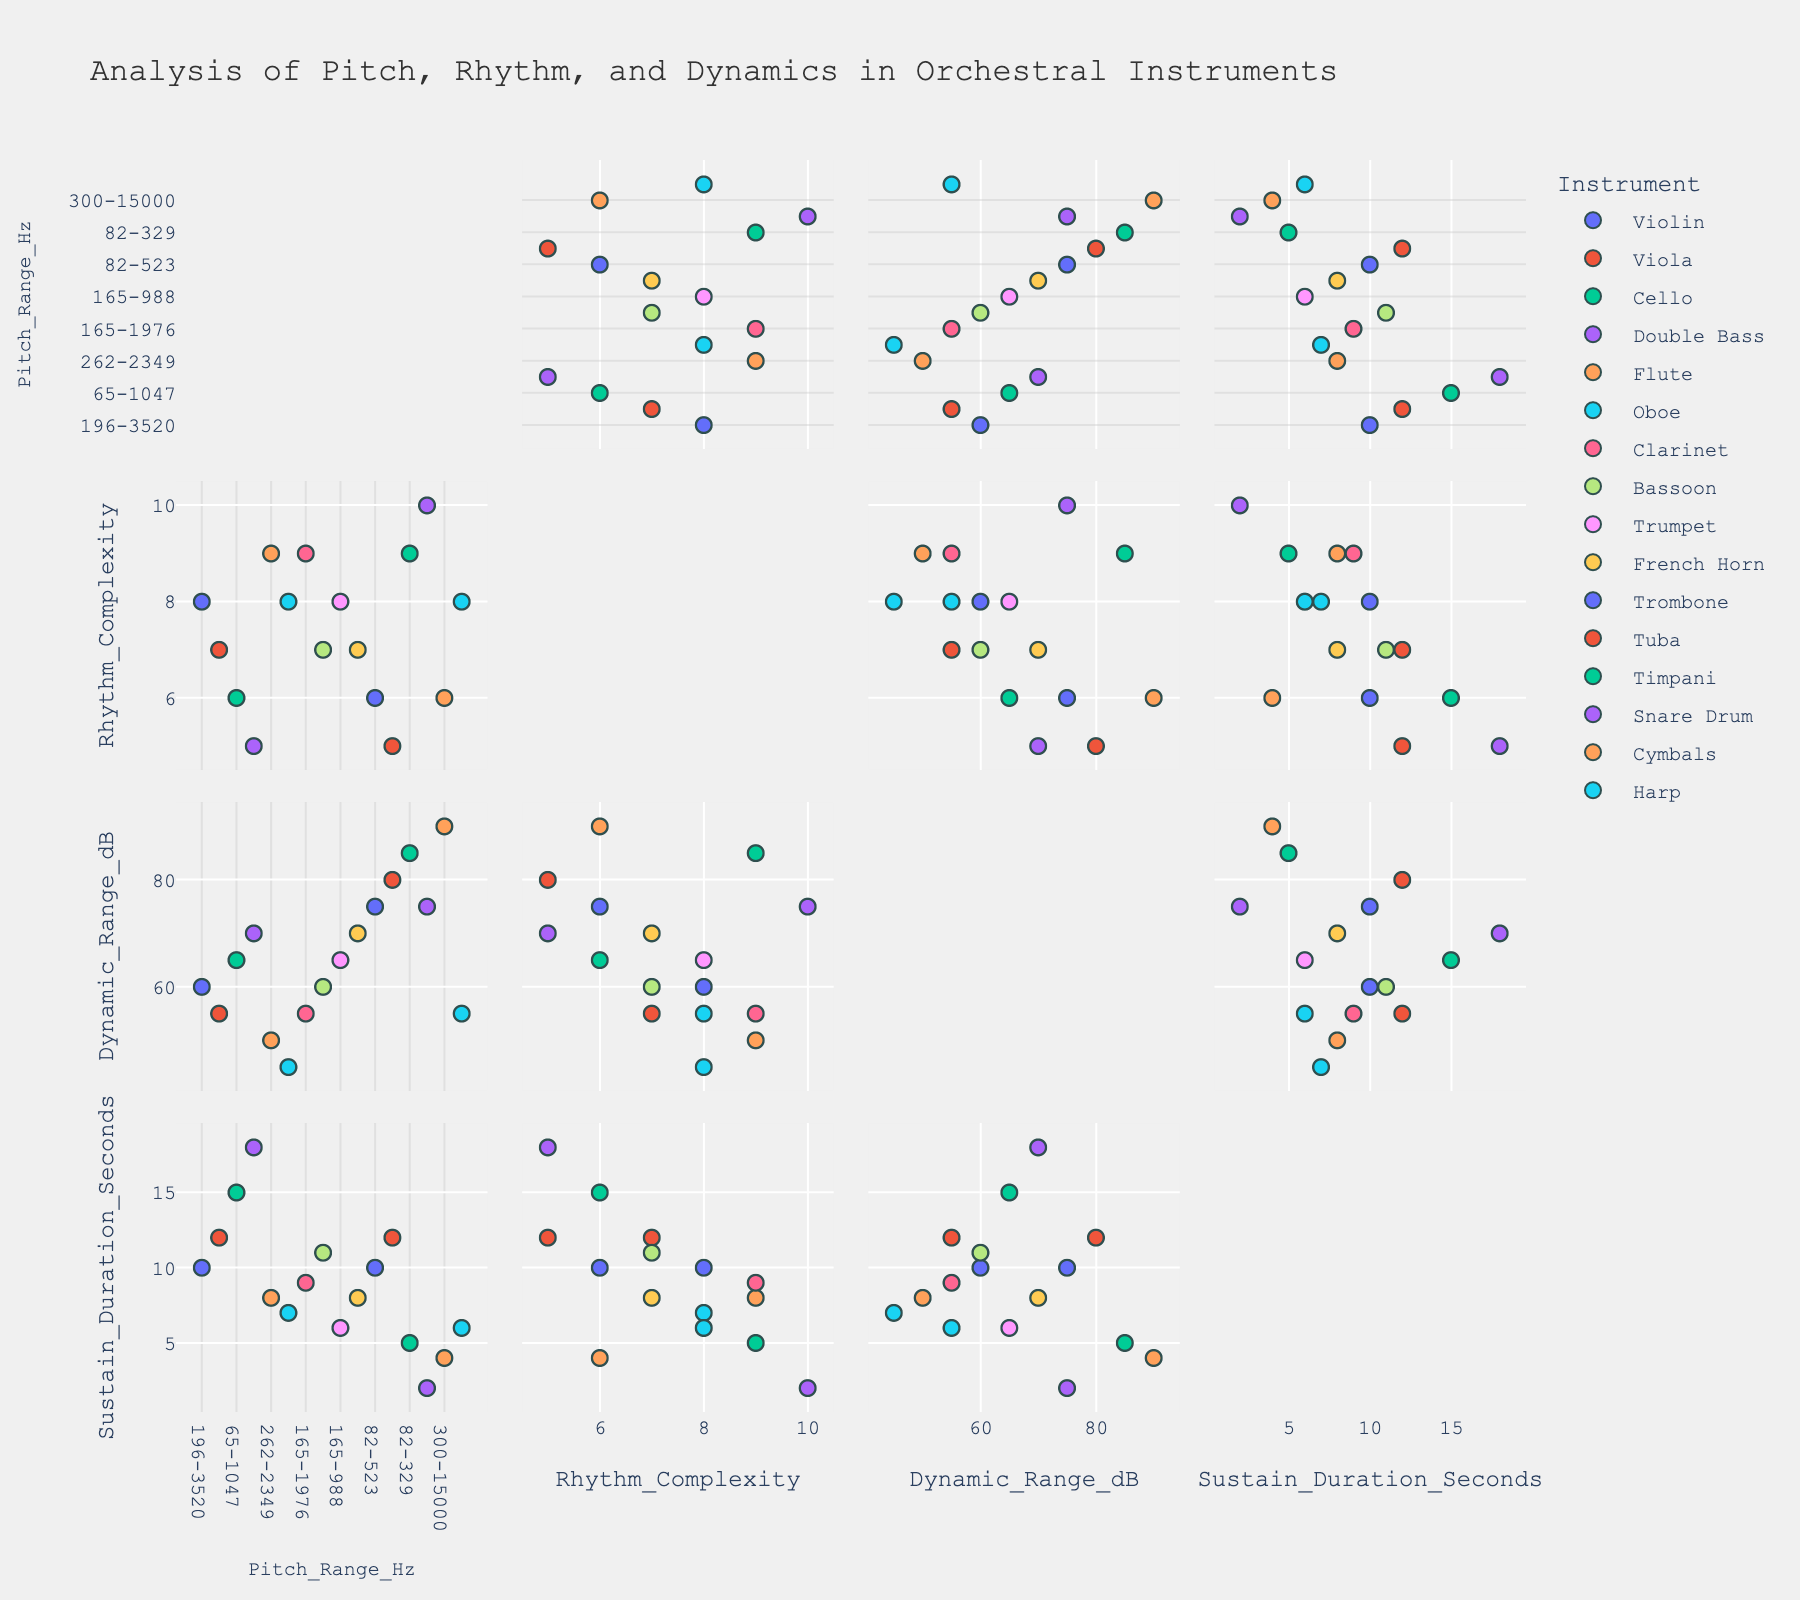What's the range of Pitch_Range_Hz for the Violin? By identifying the Violin's data point in the scatter plot matrix and reading the corresponding Pitch_Range_Hz value, we find it to be 196-3520 Hz.
Answer: 196-3520 Hz Which instrument has the highest Dynamic_Range_dB? Identify the data point with the highest value in the Dynamic_Range_dB axis. The highest point corresponds to the Cymbals with a dynamic range of 90 dB.
Answer: Cymbals What is the average Sustain_Duration_Seconds for the Double Bass and Cello? Locate the data points for the Double Bass and Cello, noting their Sustain_Duration_Seconds values: 18 and 15 seconds respectively. The average is calculated as (18 + 15) / 2 = 16.5 seconds.
Answer: 16.5 seconds Do woodwind instruments generally have higher Rhythm_Complexity than brass instruments? Compare the Rhythm_Complexity values of woodwind instruments (Flute, Oboe, Clarinet, Bassoon) with those of brass instruments (Trumpet, French Horn, Trombone, Tuba). Woodwinds mostly fall within 7-9, while brass instruments are primarily 5-8, indicating woodwinds generally have higher Rhythm_Complexity.
Answer: Yes Which instrument shows the shortest Sustain_Duration_Seconds, and what is it? Identify the shortest point on the Sustain_Duration_Seconds axis, which corresponds to the Snare Drum with 2 seconds.
Answer: Snare Drum, 2 seconds Among the string instruments, which has the widest Pitch_Range_Hz? Compare the Pitch_Range_Hz of the Violin, Viola, Cello, and Double Bass. The Harp is also a string instrument with a range of 31-3951 Hz. This is wider compared to other string instruments.
Answer: Harp Is there a correlation between Rhythm_Complexity and Dynamic_Range_dB? Visually analyze the scatter plots of Rhythm_Complexity versus Dynamic_Range_dB. Correlation would show as a pattern, whereas a lack of correlation shows scattered points with no clear trend. The plot suggests there is no strong correlation.
Answer: No What is the Pitch_Range_Hz for the Trumpet in comparison to the Trombone? Identifying their data points, the Trumpet's Pitch_Range_Hz is 165-988 Hz, whereas the Trombone's is 82-523 Hz.
Answer: Trumpet: 165-988 Hz, Trombone: 82-523 Hz What’s the median Dynamic_Range_dB value across all instruments? List the Dynamic_Range_dB values: 60, 55, 65, 70, 50, 45, 55, 60, 65, 70, 75, 80, 85, 75, 90, 55. Sorting them we get: 45, 50, 55, 55, 55, 60, 60, 65, 65, 70, 70, 75, 75, 80, 85, 90. The median is the average of the 8th and 9th values: (65 + 65) / 2 = 65.
Answer: 65 What is the difference in Sustain_Duration_Seconds between the Harp and the Timpani? Identify their Sustain_Duration_Seconds: Harp has 6 seconds, Timpani has 5 seconds. The difference is 6 - 5 = 1 second.
Answer: 1 second 